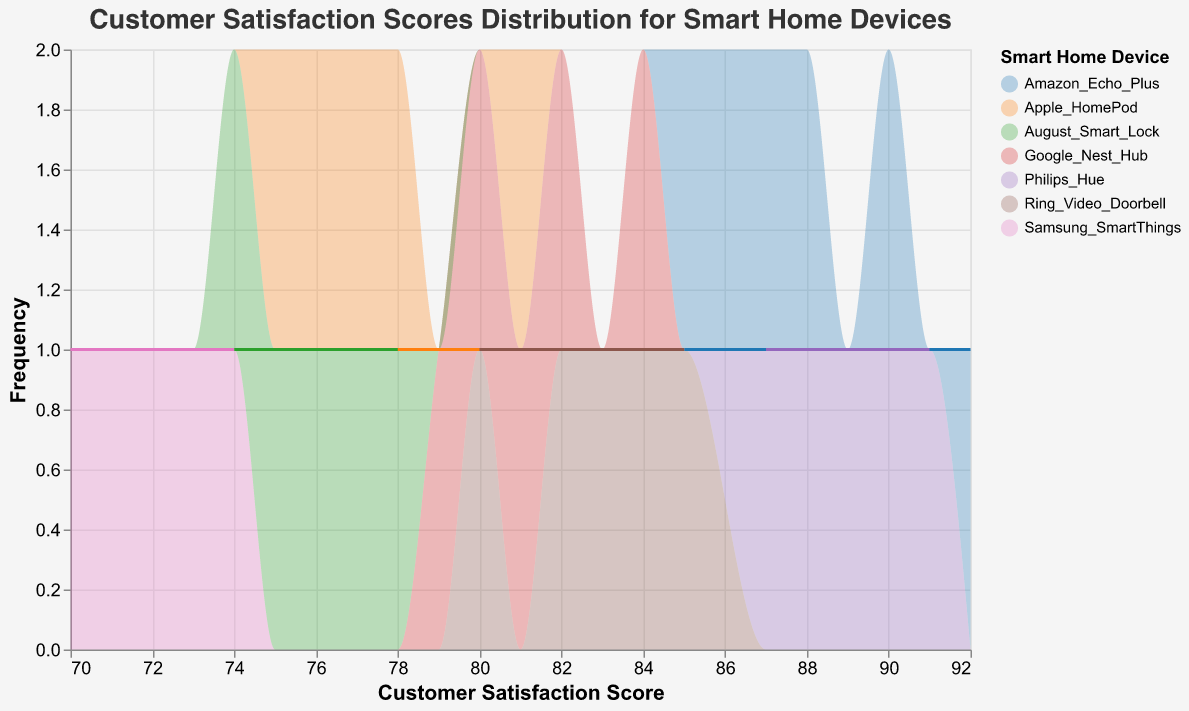What is the title of the figure? The title of the figure is usually displayed at the top, indicating the main subject or insight the figure is providing.
Answer: Customer Satisfaction Scores Distribution for Smart Home Devices Which device shows the highest customer satisfaction score? By looking at the highest points on the x-axis for each device, we can identify that "Amazon Echo Plus" and "Philips Hue" have scores reaching up to 92 and 91 respectively. Among these, the highest score is from "Amazon Echo Plus."
Answer: Amazon Echo Plus Which device has the lowest range of customer satisfaction scores? By examining the spread of scores along the x-axis for each device, we can determine that "Samsung SmartThings" has the lowest scores ranging from 70 to 74, indicating the narrowest range.
Answer: Samsung SmartThings What is the satisfaction score range for Google Nest Hub? By checking the distribution peaks along the x-axis for "Google Nest Hub," we can see it ranges from 79 to 84.
Answer: 79 to 84 Which device has the highest frequency of customer satisfaction scores of 88? By observing the peaks of the area charts at the score of 88 on the x-axis, "Philips Hue" displays a marked frequency at this score.
Answer: Philips Hue Which device has the most consistent customer satisfaction scores? The consistency can be determined by evaluating the concentration of scores on the x-axis. "Apple HomePod" shows scores that are closely clustered between 75 to 81, indicating high consistency.
Answer: Apple HomePod Which device has satisfaction scores that span across the widest range? By examining the range of scores on the x-axis for all devices, "Amazon Echo Plus" has the widest range, spanning from 85 to 92.
Answer: Amazon Echo Plus 